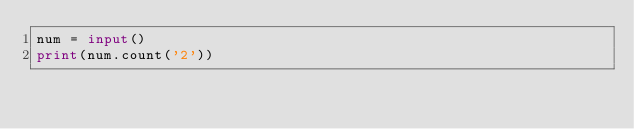Convert code to text. <code><loc_0><loc_0><loc_500><loc_500><_Python_>num = input()
print(num.count('2'))</code> 